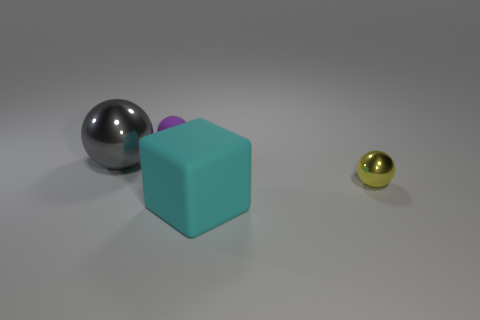Subtract all yellow spheres. How many spheres are left? 2 Subtract 1 cubes. How many cubes are left? 0 Subtract all gray balls. How many balls are left? 2 Add 2 cyan metallic balls. How many objects exist? 6 Subtract 0 gray cubes. How many objects are left? 4 Subtract all cubes. How many objects are left? 3 Subtract all red spheres. Subtract all red cylinders. How many spheres are left? 3 Subtract all green blocks. How many gray spheres are left? 1 Subtract all large purple matte things. Subtract all big objects. How many objects are left? 2 Add 4 small yellow balls. How many small yellow balls are left? 5 